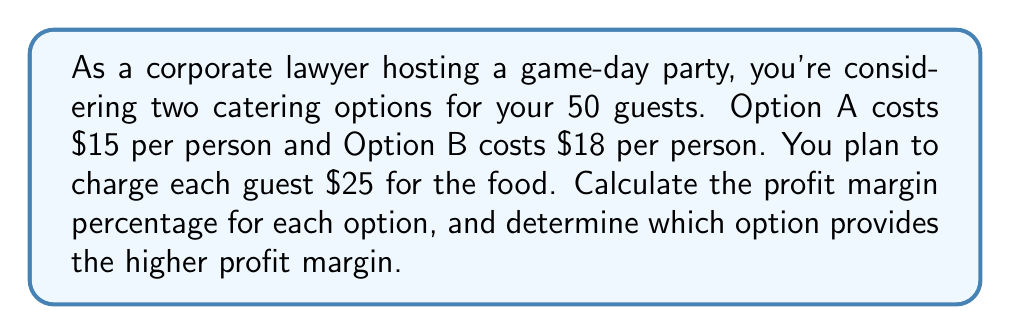Provide a solution to this math problem. To solve this problem, we'll follow these steps for each option:

1. Calculate the total revenue
2. Calculate the total cost
3. Calculate the profit
4. Calculate the profit margin percentage

For both options:
Revenue per person = $25
Number of guests = 50
Total revenue = $25 × 50 = $1250

Option A:
1. Total revenue = $1250
2. Cost per person = $15
   Total cost = $15 × 50 = $750
3. Profit = Total revenue - Total cost
   $1250 - $750 = $500
4. Profit margin percentage = (Profit ÷ Revenue) × 100%
   $$(500 \div 1250) \times 100\% = 40\%$$

Option B:
1. Total revenue = $1250
2. Cost per person = $18
   Total cost = $18 × 50 = $900
3. Profit = Total revenue - Total cost
   $1250 - $900 = $350
4. Profit margin percentage = (Profit ÷ Revenue) × 100%
   $$(350 \div 1250) \times 100\% = 28\%$$

Comparing the profit margins:
Option A: 40%
Option B: 28%

Option A provides the higher profit margin.
Answer: Option A has a profit margin of 40%, while Option B has a profit margin of 28%. Therefore, Option A provides the higher profit margin. 